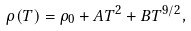<formula> <loc_0><loc_0><loc_500><loc_500>\rho ( T ) = \rho _ { 0 } + A T ^ { 2 } + B T ^ { 9 / 2 } ,</formula> 